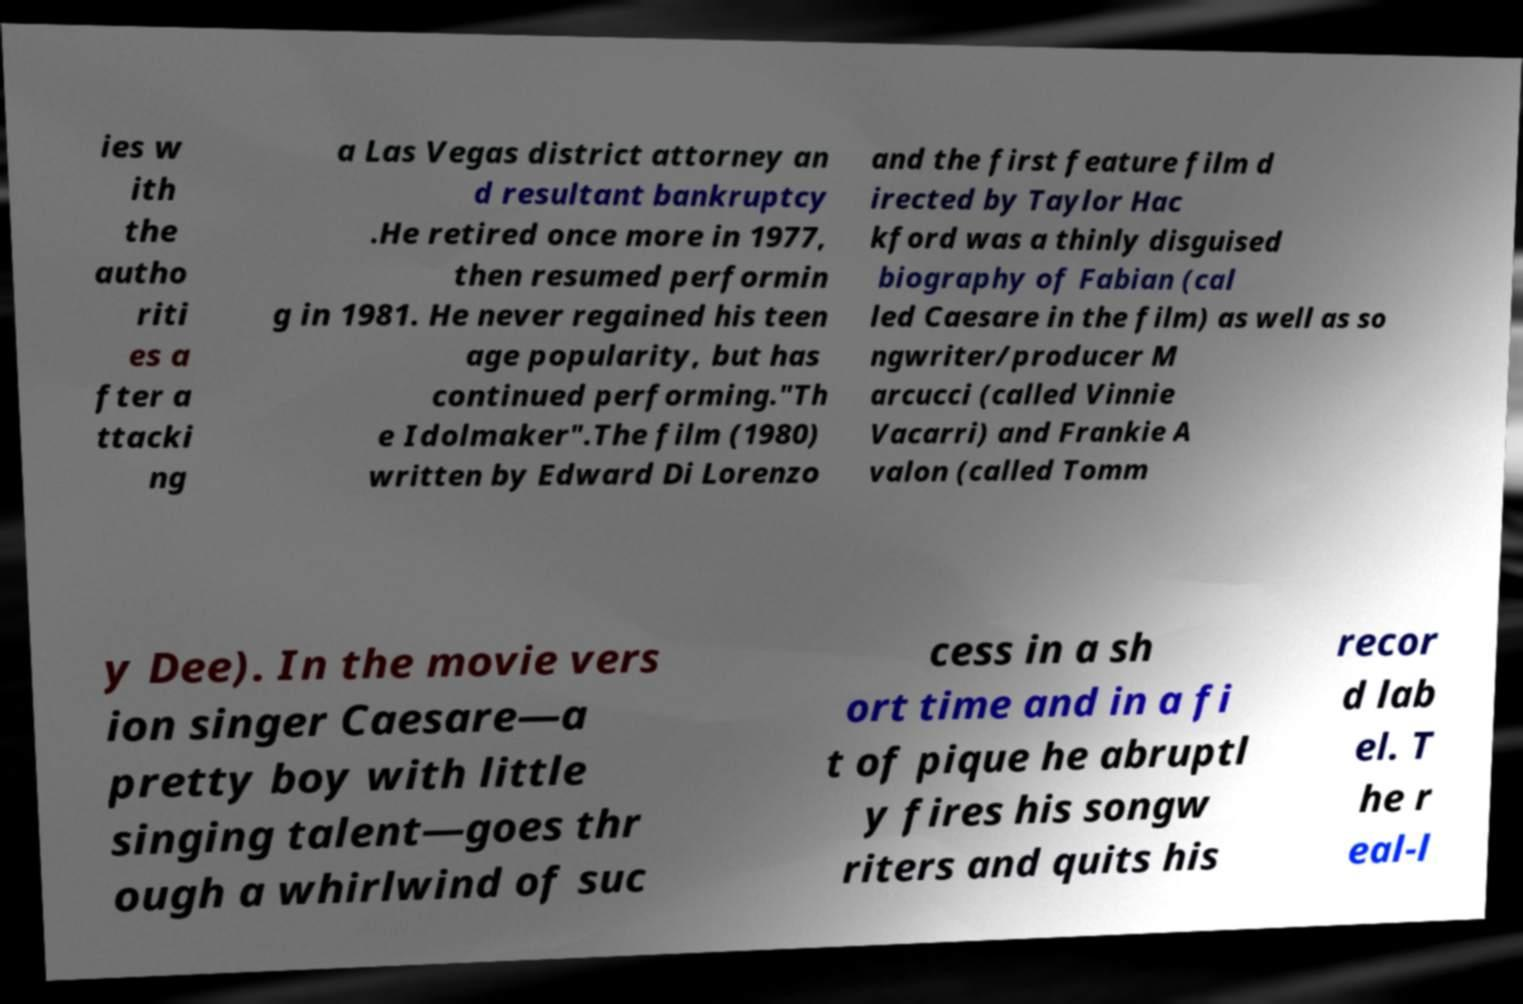Please identify and transcribe the text found in this image. ies w ith the autho riti es a fter a ttacki ng a Las Vegas district attorney an d resultant bankruptcy .He retired once more in 1977, then resumed performin g in 1981. He never regained his teen age popularity, but has continued performing."Th e Idolmaker".The film (1980) written by Edward Di Lorenzo and the first feature film d irected by Taylor Hac kford was a thinly disguised biography of Fabian (cal led Caesare in the film) as well as so ngwriter/producer M arcucci (called Vinnie Vacarri) and Frankie A valon (called Tomm y Dee). In the movie vers ion singer Caesare—a pretty boy with little singing talent—goes thr ough a whirlwind of suc cess in a sh ort time and in a fi t of pique he abruptl y fires his songw riters and quits his recor d lab el. T he r eal-l 